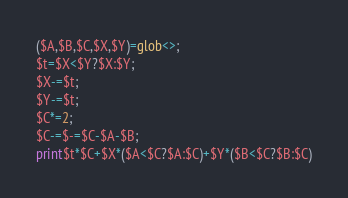<code> <loc_0><loc_0><loc_500><loc_500><_Perl_>($A,$B,$C,$X,$Y)=glob<>;
$t=$X<$Y?$X:$Y;
$X-=$t;
$Y-=$t;
$C*=2;
$C-=$-=$C-$A-$B;
print$t*$C+$X*($A<$C?$A:$C)+$Y*($B<$C?$B:$C)
</code> 